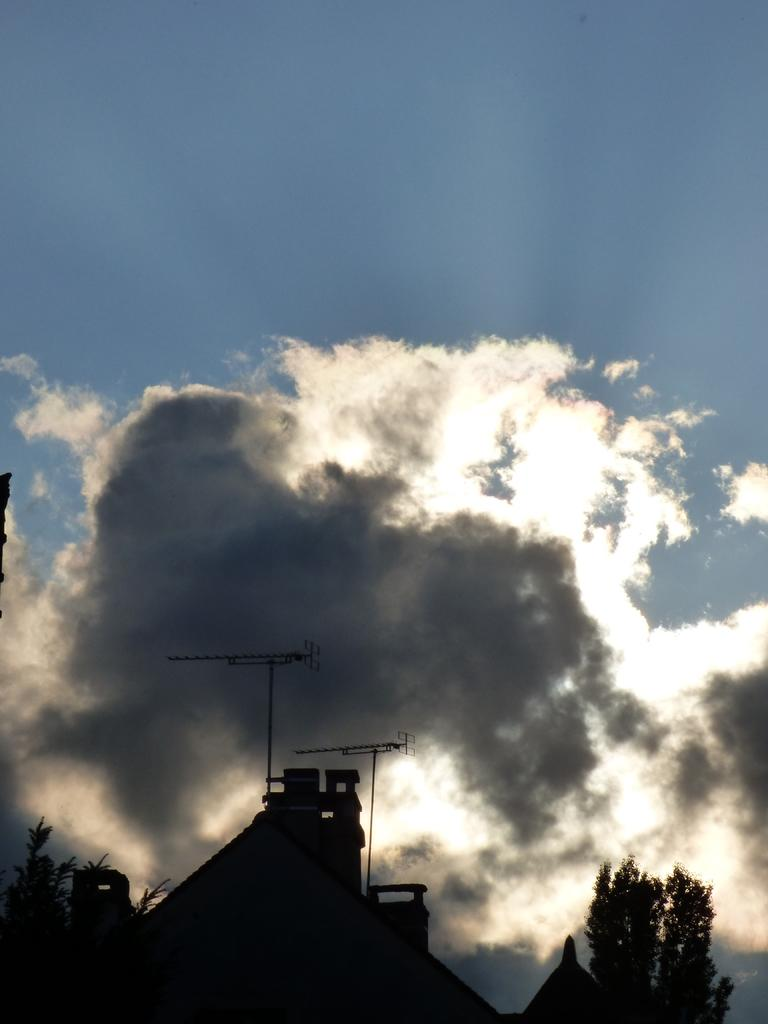What type of structures can be seen in the image? There are buildings in the image. What other natural elements are present in the image? There are trees in the image. What is on top of the buildings? There are poles on top of the buildings. What is visible at the top of the image? The sky is visible at the top of the image. What can be seen in the sky? There are clouds in the sky. What type of car is visible in the frame of the image? There is no car present in the image. What type of slave can be seen working in the background of the image? There is no slave present in the image; it only features buildings, trees, poles, and clouds. 